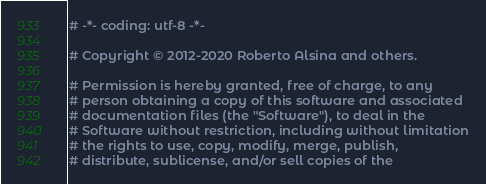<code> <loc_0><loc_0><loc_500><loc_500><_Python_># -*- coding: utf-8 -*-

# Copyright © 2012-2020 Roberto Alsina and others.

# Permission is hereby granted, free of charge, to any
# person obtaining a copy of this software and associated
# documentation files (the "Software"), to deal in the
# Software without restriction, including without limitation
# the rights to use, copy, modify, merge, publish,
# distribute, sublicense, and/or sell copies of the</code> 